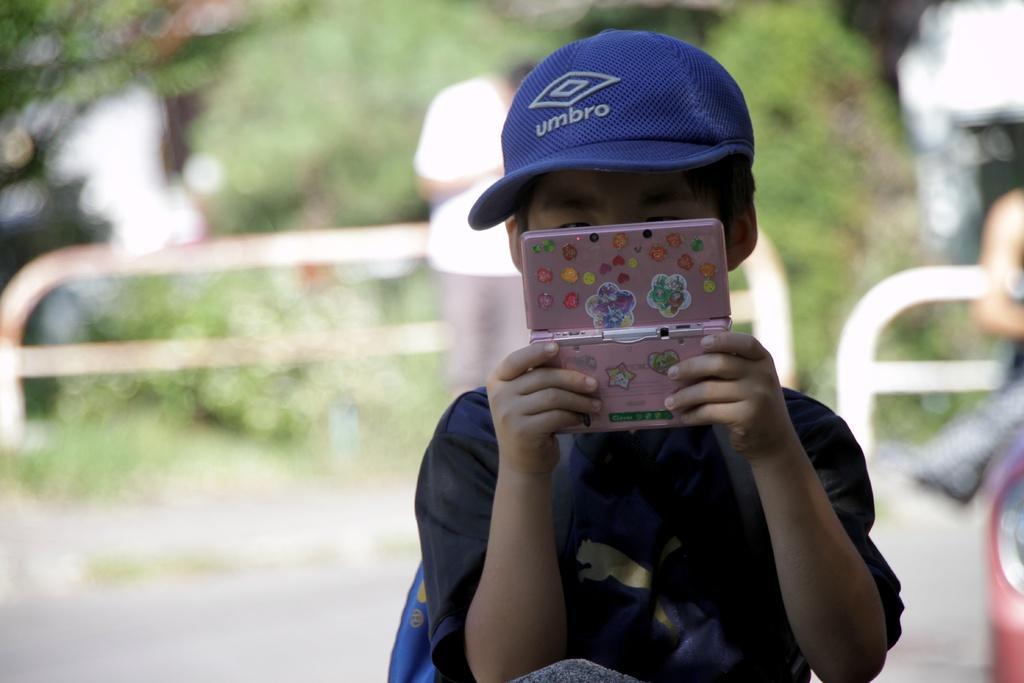Please provide a concise description of this image. In this image we can see a boy. He is holding a pink color object in her hand. In the background, we can see people, fence, road and greenery. 